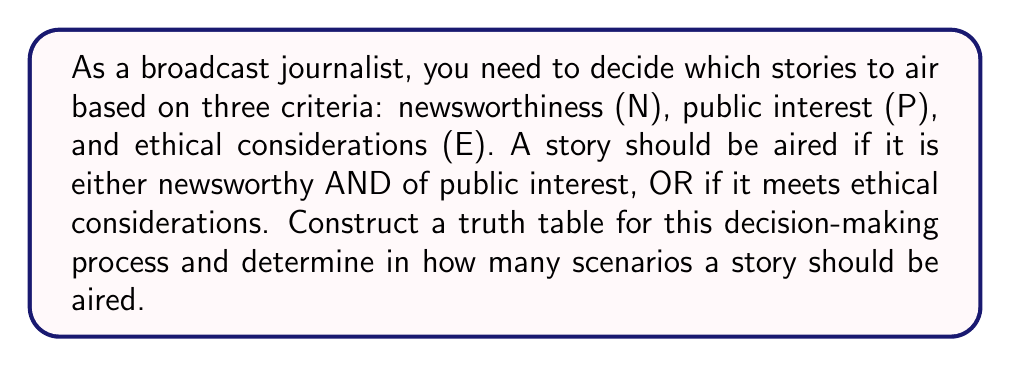Can you solve this math problem? Let's approach this step-by-step:

1) First, we need to translate the given conditions into a Boolean expression:
   $$(N \wedge P) \vee E$$

2) Now, let's create a truth table with all possible combinations of N, P, and E:

   $$\begin{array}{|c|c|c|c|c|c|}
   \hline
   N & P & E & N \wedge P & (N \wedge P) \vee E & \text{Air?} \\
   \hline
   0 & 0 & 0 & 0 & 0 & \text{No} \\
   0 & 0 & 1 & 0 & 1 & \text{Yes} \\
   0 & 1 & 0 & 0 & 0 & \text{No} \\
   0 & 1 & 1 & 0 & 1 & \text{Yes} \\
   1 & 0 & 0 & 0 & 0 & \text{No} \\
   1 & 0 & 1 & 0 & 1 & \text{Yes} \\
   1 & 1 & 0 & 1 & 1 & \text{Yes} \\
   1 & 1 & 1 & 1 & 1 & \text{Yes} \\
   \hline
   \end{array}$$

3) In this table:
   - $N \wedge P$ represents "newsworthy AND of public interest"
   - $(N \wedge P) \vee E$ represents the full condition for airing a story

4) Counting the number of rows where the final column is "Yes", we find that there are 5 scenarios where a story should be aired.
Answer: 5 scenarios 